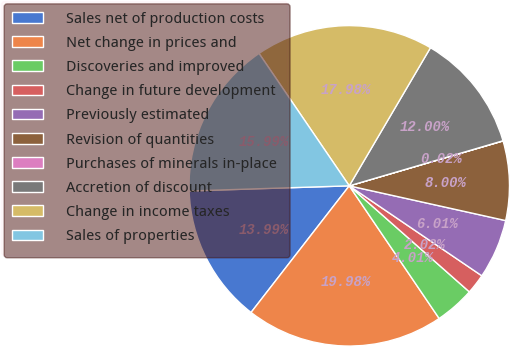<chart> <loc_0><loc_0><loc_500><loc_500><pie_chart><fcel>Sales net of production costs<fcel>Net change in prices and<fcel>Discoveries and improved<fcel>Change in future development<fcel>Previously estimated<fcel>Revision of quantities<fcel>Purchases of minerals in-place<fcel>Accretion of discount<fcel>Change in income taxes<fcel>Sales of properties<nl><fcel>13.99%<fcel>19.98%<fcel>4.01%<fcel>2.02%<fcel>6.01%<fcel>8.0%<fcel>0.02%<fcel>12.0%<fcel>17.98%<fcel>15.99%<nl></chart> 